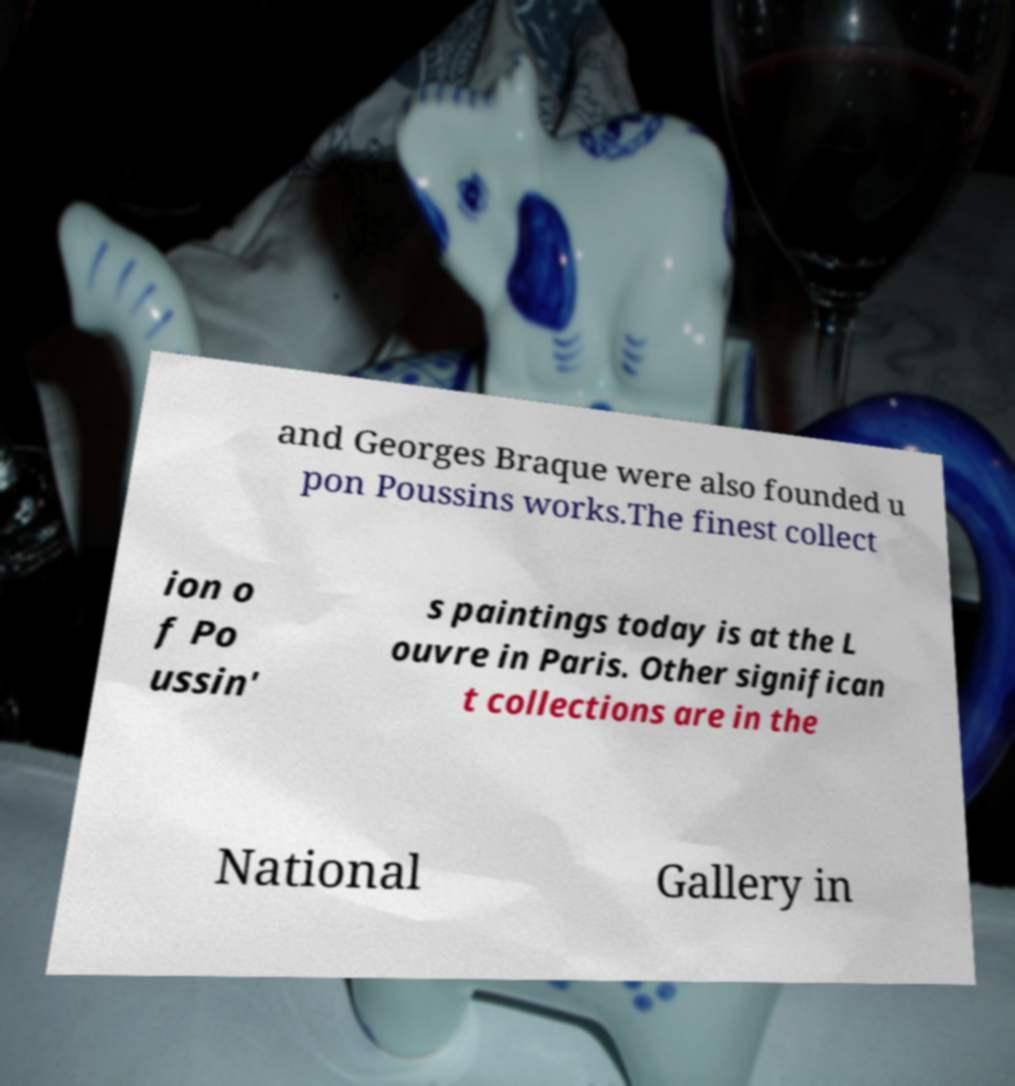There's text embedded in this image that I need extracted. Can you transcribe it verbatim? and Georges Braque were also founded u pon Poussins works.The finest collect ion o f Po ussin' s paintings today is at the L ouvre in Paris. Other significan t collections are in the National Gallery in 